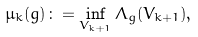<formula> <loc_0><loc_0><loc_500><loc_500>\mu _ { k } ( g ) \colon = \inf _ { V _ { k + 1 } } \Lambda _ { g } ( V _ { k + 1 } ) ,</formula> 